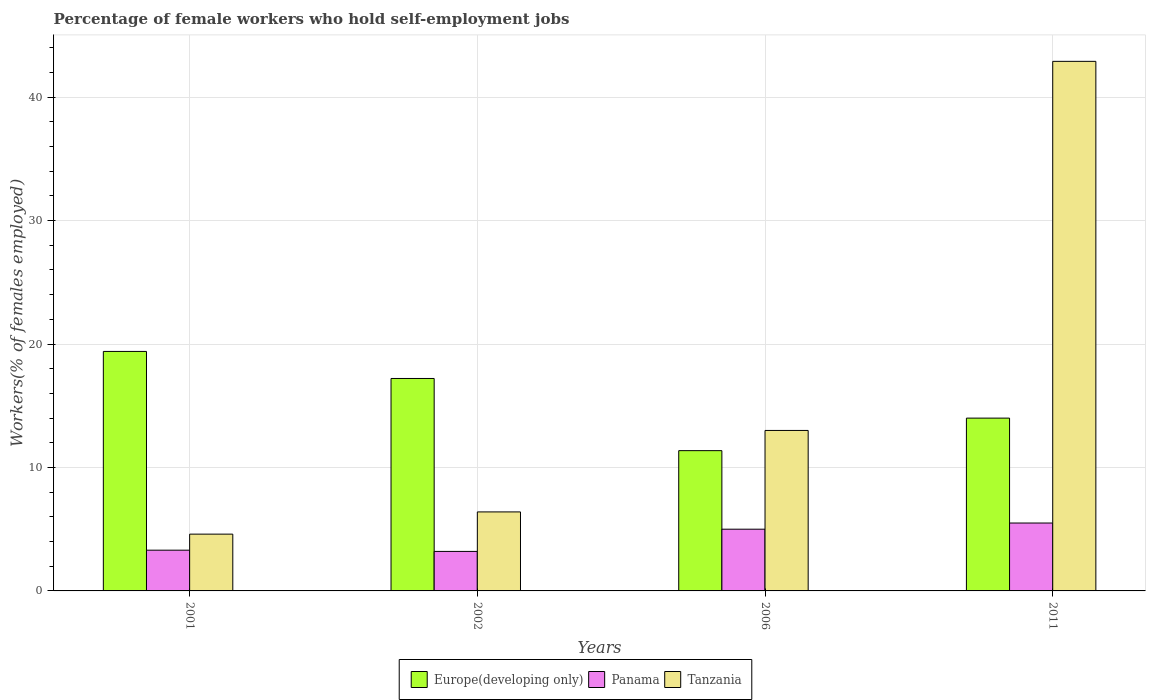How many different coloured bars are there?
Your answer should be compact. 3. How many bars are there on the 3rd tick from the right?
Your answer should be very brief. 3. In how many cases, is the number of bars for a given year not equal to the number of legend labels?
Your response must be concise. 0. Across all years, what is the maximum percentage of self-employed female workers in Panama?
Make the answer very short. 5.5. Across all years, what is the minimum percentage of self-employed female workers in Europe(developing only)?
Give a very brief answer. 11.36. In which year was the percentage of self-employed female workers in Panama maximum?
Provide a short and direct response. 2011. What is the total percentage of self-employed female workers in Europe(developing only) in the graph?
Provide a succinct answer. 61.97. What is the difference between the percentage of self-employed female workers in Europe(developing only) in 2002 and that in 2006?
Your answer should be very brief. 5.85. What is the difference between the percentage of self-employed female workers in Tanzania in 2011 and the percentage of self-employed female workers in Europe(developing only) in 2006?
Keep it short and to the point. 31.54. What is the average percentage of self-employed female workers in Tanzania per year?
Ensure brevity in your answer.  16.73. In the year 2006, what is the difference between the percentage of self-employed female workers in Panama and percentage of self-employed female workers in Europe(developing only)?
Provide a succinct answer. -6.36. In how many years, is the percentage of self-employed female workers in Europe(developing only) greater than 10 %?
Provide a succinct answer. 4. What is the ratio of the percentage of self-employed female workers in Europe(developing only) in 2001 to that in 2002?
Offer a very short reply. 1.13. What is the difference between the highest and the second highest percentage of self-employed female workers in Tanzania?
Offer a terse response. 29.9. What is the difference between the highest and the lowest percentage of self-employed female workers in Europe(developing only)?
Your response must be concise. 8.04. Is the sum of the percentage of self-employed female workers in Panama in 2001 and 2006 greater than the maximum percentage of self-employed female workers in Tanzania across all years?
Keep it short and to the point. No. What does the 3rd bar from the left in 2011 represents?
Your answer should be very brief. Tanzania. What does the 1st bar from the right in 2011 represents?
Provide a short and direct response. Tanzania. How many bars are there?
Keep it short and to the point. 12. How many years are there in the graph?
Ensure brevity in your answer.  4. Are the values on the major ticks of Y-axis written in scientific E-notation?
Provide a succinct answer. No. Does the graph contain grids?
Offer a very short reply. Yes. Where does the legend appear in the graph?
Your answer should be very brief. Bottom center. How many legend labels are there?
Offer a terse response. 3. What is the title of the graph?
Your answer should be very brief. Percentage of female workers who hold self-employment jobs. What is the label or title of the Y-axis?
Offer a terse response. Workers(% of females employed). What is the Workers(% of females employed) of Europe(developing only) in 2001?
Offer a very short reply. 19.4. What is the Workers(% of females employed) in Panama in 2001?
Ensure brevity in your answer.  3.3. What is the Workers(% of females employed) of Tanzania in 2001?
Offer a very short reply. 4.6. What is the Workers(% of females employed) in Europe(developing only) in 2002?
Keep it short and to the point. 17.21. What is the Workers(% of females employed) of Panama in 2002?
Offer a very short reply. 3.2. What is the Workers(% of females employed) of Tanzania in 2002?
Keep it short and to the point. 6.4. What is the Workers(% of females employed) of Europe(developing only) in 2006?
Offer a very short reply. 11.36. What is the Workers(% of females employed) in Panama in 2006?
Your answer should be very brief. 5. What is the Workers(% of females employed) of Tanzania in 2006?
Keep it short and to the point. 13. What is the Workers(% of females employed) of Europe(developing only) in 2011?
Give a very brief answer. 14. What is the Workers(% of females employed) of Tanzania in 2011?
Ensure brevity in your answer.  42.9. Across all years, what is the maximum Workers(% of females employed) in Europe(developing only)?
Offer a very short reply. 19.4. Across all years, what is the maximum Workers(% of females employed) of Panama?
Your answer should be very brief. 5.5. Across all years, what is the maximum Workers(% of females employed) of Tanzania?
Make the answer very short. 42.9. Across all years, what is the minimum Workers(% of females employed) of Europe(developing only)?
Make the answer very short. 11.36. Across all years, what is the minimum Workers(% of females employed) of Panama?
Offer a terse response. 3.2. Across all years, what is the minimum Workers(% of females employed) of Tanzania?
Provide a short and direct response. 4.6. What is the total Workers(% of females employed) of Europe(developing only) in the graph?
Ensure brevity in your answer.  61.97. What is the total Workers(% of females employed) of Panama in the graph?
Your answer should be compact. 17. What is the total Workers(% of females employed) in Tanzania in the graph?
Make the answer very short. 66.9. What is the difference between the Workers(% of females employed) in Europe(developing only) in 2001 and that in 2002?
Make the answer very short. 2.19. What is the difference between the Workers(% of females employed) of Tanzania in 2001 and that in 2002?
Offer a terse response. -1.8. What is the difference between the Workers(% of females employed) in Europe(developing only) in 2001 and that in 2006?
Keep it short and to the point. 8.04. What is the difference between the Workers(% of females employed) in Europe(developing only) in 2001 and that in 2011?
Your response must be concise. 5.4. What is the difference between the Workers(% of females employed) of Tanzania in 2001 and that in 2011?
Make the answer very short. -38.3. What is the difference between the Workers(% of females employed) of Europe(developing only) in 2002 and that in 2006?
Offer a very short reply. 5.85. What is the difference between the Workers(% of females employed) of Europe(developing only) in 2002 and that in 2011?
Offer a very short reply. 3.21. What is the difference between the Workers(% of females employed) in Tanzania in 2002 and that in 2011?
Ensure brevity in your answer.  -36.5. What is the difference between the Workers(% of females employed) of Europe(developing only) in 2006 and that in 2011?
Give a very brief answer. -2.64. What is the difference between the Workers(% of females employed) of Panama in 2006 and that in 2011?
Offer a terse response. -0.5. What is the difference between the Workers(% of females employed) of Tanzania in 2006 and that in 2011?
Give a very brief answer. -29.9. What is the difference between the Workers(% of females employed) of Europe(developing only) in 2001 and the Workers(% of females employed) of Panama in 2002?
Your response must be concise. 16.2. What is the difference between the Workers(% of females employed) of Europe(developing only) in 2001 and the Workers(% of females employed) of Tanzania in 2002?
Offer a very short reply. 13. What is the difference between the Workers(% of females employed) in Panama in 2001 and the Workers(% of females employed) in Tanzania in 2002?
Make the answer very short. -3.1. What is the difference between the Workers(% of females employed) in Europe(developing only) in 2001 and the Workers(% of females employed) in Panama in 2006?
Make the answer very short. 14.4. What is the difference between the Workers(% of females employed) in Europe(developing only) in 2001 and the Workers(% of females employed) in Tanzania in 2006?
Keep it short and to the point. 6.4. What is the difference between the Workers(% of females employed) in Europe(developing only) in 2001 and the Workers(% of females employed) in Panama in 2011?
Your answer should be compact. 13.9. What is the difference between the Workers(% of females employed) of Europe(developing only) in 2001 and the Workers(% of females employed) of Tanzania in 2011?
Your response must be concise. -23.5. What is the difference between the Workers(% of females employed) of Panama in 2001 and the Workers(% of females employed) of Tanzania in 2011?
Offer a terse response. -39.6. What is the difference between the Workers(% of females employed) in Europe(developing only) in 2002 and the Workers(% of females employed) in Panama in 2006?
Your response must be concise. 12.21. What is the difference between the Workers(% of females employed) in Europe(developing only) in 2002 and the Workers(% of females employed) in Tanzania in 2006?
Your response must be concise. 4.21. What is the difference between the Workers(% of females employed) in Panama in 2002 and the Workers(% of females employed) in Tanzania in 2006?
Ensure brevity in your answer.  -9.8. What is the difference between the Workers(% of females employed) in Europe(developing only) in 2002 and the Workers(% of females employed) in Panama in 2011?
Keep it short and to the point. 11.71. What is the difference between the Workers(% of females employed) of Europe(developing only) in 2002 and the Workers(% of females employed) of Tanzania in 2011?
Your answer should be compact. -25.69. What is the difference between the Workers(% of females employed) of Panama in 2002 and the Workers(% of females employed) of Tanzania in 2011?
Make the answer very short. -39.7. What is the difference between the Workers(% of females employed) of Europe(developing only) in 2006 and the Workers(% of females employed) of Panama in 2011?
Your answer should be very brief. 5.86. What is the difference between the Workers(% of females employed) in Europe(developing only) in 2006 and the Workers(% of females employed) in Tanzania in 2011?
Your answer should be compact. -31.54. What is the difference between the Workers(% of females employed) in Panama in 2006 and the Workers(% of females employed) in Tanzania in 2011?
Provide a short and direct response. -37.9. What is the average Workers(% of females employed) of Europe(developing only) per year?
Your response must be concise. 15.49. What is the average Workers(% of females employed) of Panama per year?
Provide a short and direct response. 4.25. What is the average Workers(% of females employed) in Tanzania per year?
Your answer should be very brief. 16.73. In the year 2001, what is the difference between the Workers(% of females employed) in Europe(developing only) and Workers(% of females employed) in Panama?
Give a very brief answer. 16.1. In the year 2001, what is the difference between the Workers(% of females employed) of Europe(developing only) and Workers(% of females employed) of Tanzania?
Keep it short and to the point. 14.8. In the year 2001, what is the difference between the Workers(% of females employed) of Panama and Workers(% of females employed) of Tanzania?
Offer a very short reply. -1.3. In the year 2002, what is the difference between the Workers(% of females employed) of Europe(developing only) and Workers(% of females employed) of Panama?
Your answer should be compact. 14.01. In the year 2002, what is the difference between the Workers(% of females employed) of Europe(developing only) and Workers(% of females employed) of Tanzania?
Provide a short and direct response. 10.81. In the year 2002, what is the difference between the Workers(% of females employed) of Panama and Workers(% of females employed) of Tanzania?
Your answer should be compact. -3.2. In the year 2006, what is the difference between the Workers(% of females employed) in Europe(developing only) and Workers(% of females employed) in Panama?
Your answer should be compact. 6.36. In the year 2006, what is the difference between the Workers(% of females employed) of Europe(developing only) and Workers(% of females employed) of Tanzania?
Give a very brief answer. -1.64. In the year 2006, what is the difference between the Workers(% of females employed) in Panama and Workers(% of females employed) in Tanzania?
Your answer should be compact. -8. In the year 2011, what is the difference between the Workers(% of females employed) of Europe(developing only) and Workers(% of females employed) of Panama?
Your answer should be very brief. 8.5. In the year 2011, what is the difference between the Workers(% of females employed) of Europe(developing only) and Workers(% of females employed) of Tanzania?
Ensure brevity in your answer.  -28.9. In the year 2011, what is the difference between the Workers(% of females employed) of Panama and Workers(% of females employed) of Tanzania?
Offer a terse response. -37.4. What is the ratio of the Workers(% of females employed) in Europe(developing only) in 2001 to that in 2002?
Your answer should be very brief. 1.13. What is the ratio of the Workers(% of females employed) in Panama in 2001 to that in 2002?
Provide a short and direct response. 1.03. What is the ratio of the Workers(% of females employed) of Tanzania in 2001 to that in 2002?
Ensure brevity in your answer.  0.72. What is the ratio of the Workers(% of females employed) of Europe(developing only) in 2001 to that in 2006?
Your answer should be very brief. 1.71. What is the ratio of the Workers(% of females employed) in Panama in 2001 to that in 2006?
Your response must be concise. 0.66. What is the ratio of the Workers(% of females employed) in Tanzania in 2001 to that in 2006?
Offer a very short reply. 0.35. What is the ratio of the Workers(% of females employed) in Europe(developing only) in 2001 to that in 2011?
Your response must be concise. 1.39. What is the ratio of the Workers(% of females employed) in Panama in 2001 to that in 2011?
Offer a terse response. 0.6. What is the ratio of the Workers(% of females employed) of Tanzania in 2001 to that in 2011?
Give a very brief answer. 0.11. What is the ratio of the Workers(% of females employed) of Europe(developing only) in 2002 to that in 2006?
Give a very brief answer. 1.51. What is the ratio of the Workers(% of females employed) in Panama in 2002 to that in 2006?
Your response must be concise. 0.64. What is the ratio of the Workers(% of females employed) of Tanzania in 2002 to that in 2006?
Provide a succinct answer. 0.49. What is the ratio of the Workers(% of females employed) of Europe(developing only) in 2002 to that in 2011?
Give a very brief answer. 1.23. What is the ratio of the Workers(% of females employed) in Panama in 2002 to that in 2011?
Give a very brief answer. 0.58. What is the ratio of the Workers(% of females employed) of Tanzania in 2002 to that in 2011?
Your response must be concise. 0.15. What is the ratio of the Workers(% of females employed) of Europe(developing only) in 2006 to that in 2011?
Ensure brevity in your answer.  0.81. What is the ratio of the Workers(% of females employed) of Tanzania in 2006 to that in 2011?
Keep it short and to the point. 0.3. What is the difference between the highest and the second highest Workers(% of females employed) of Europe(developing only)?
Offer a very short reply. 2.19. What is the difference between the highest and the second highest Workers(% of females employed) of Panama?
Give a very brief answer. 0.5. What is the difference between the highest and the second highest Workers(% of females employed) of Tanzania?
Your answer should be very brief. 29.9. What is the difference between the highest and the lowest Workers(% of females employed) of Europe(developing only)?
Your answer should be compact. 8.04. What is the difference between the highest and the lowest Workers(% of females employed) in Panama?
Ensure brevity in your answer.  2.3. What is the difference between the highest and the lowest Workers(% of females employed) of Tanzania?
Keep it short and to the point. 38.3. 